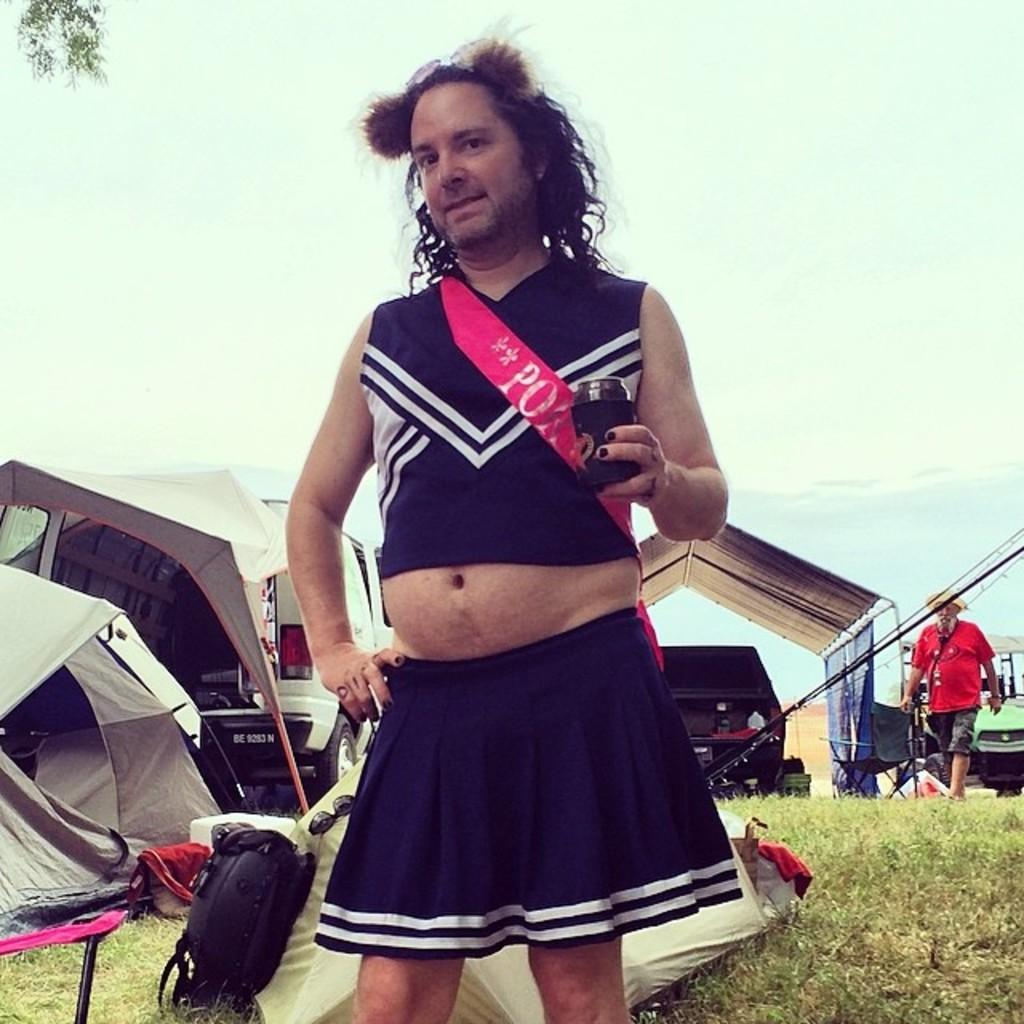Provide a one-sentence caption for the provided image. BE 9283 N is the designation of the license plate of the van. 